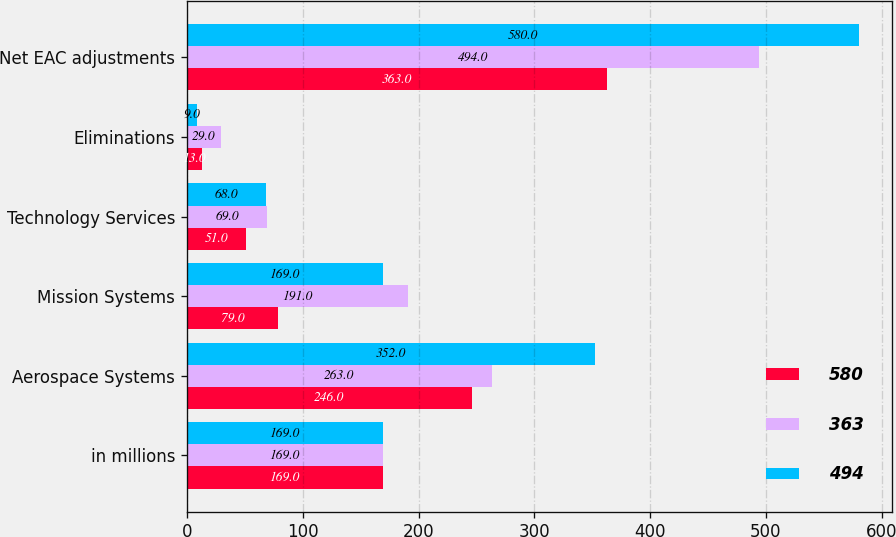Convert chart to OTSL. <chart><loc_0><loc_0><loc_500><loc_500><stacked_bar_chart><ecel><fcel>in millions<fcel>Aerospace Systems<fcel>Mission Systems<fcel>Technology Services<fcel>Eliminations<fcel>Net EAC adjustments<nl><fcel>580<fcel>169<fcel>246<fcel>79<fcel>51<fcel>13<fcel>363<nl><fcel>363<fcel>169<fcel>263<fcel>191<fcel>69<fcel>29<fcel>494<nl><fcel>494<fcel>169<fcel>352<fcel>169<fcel>68<fcel>9<fcel>580<nl></chart> 